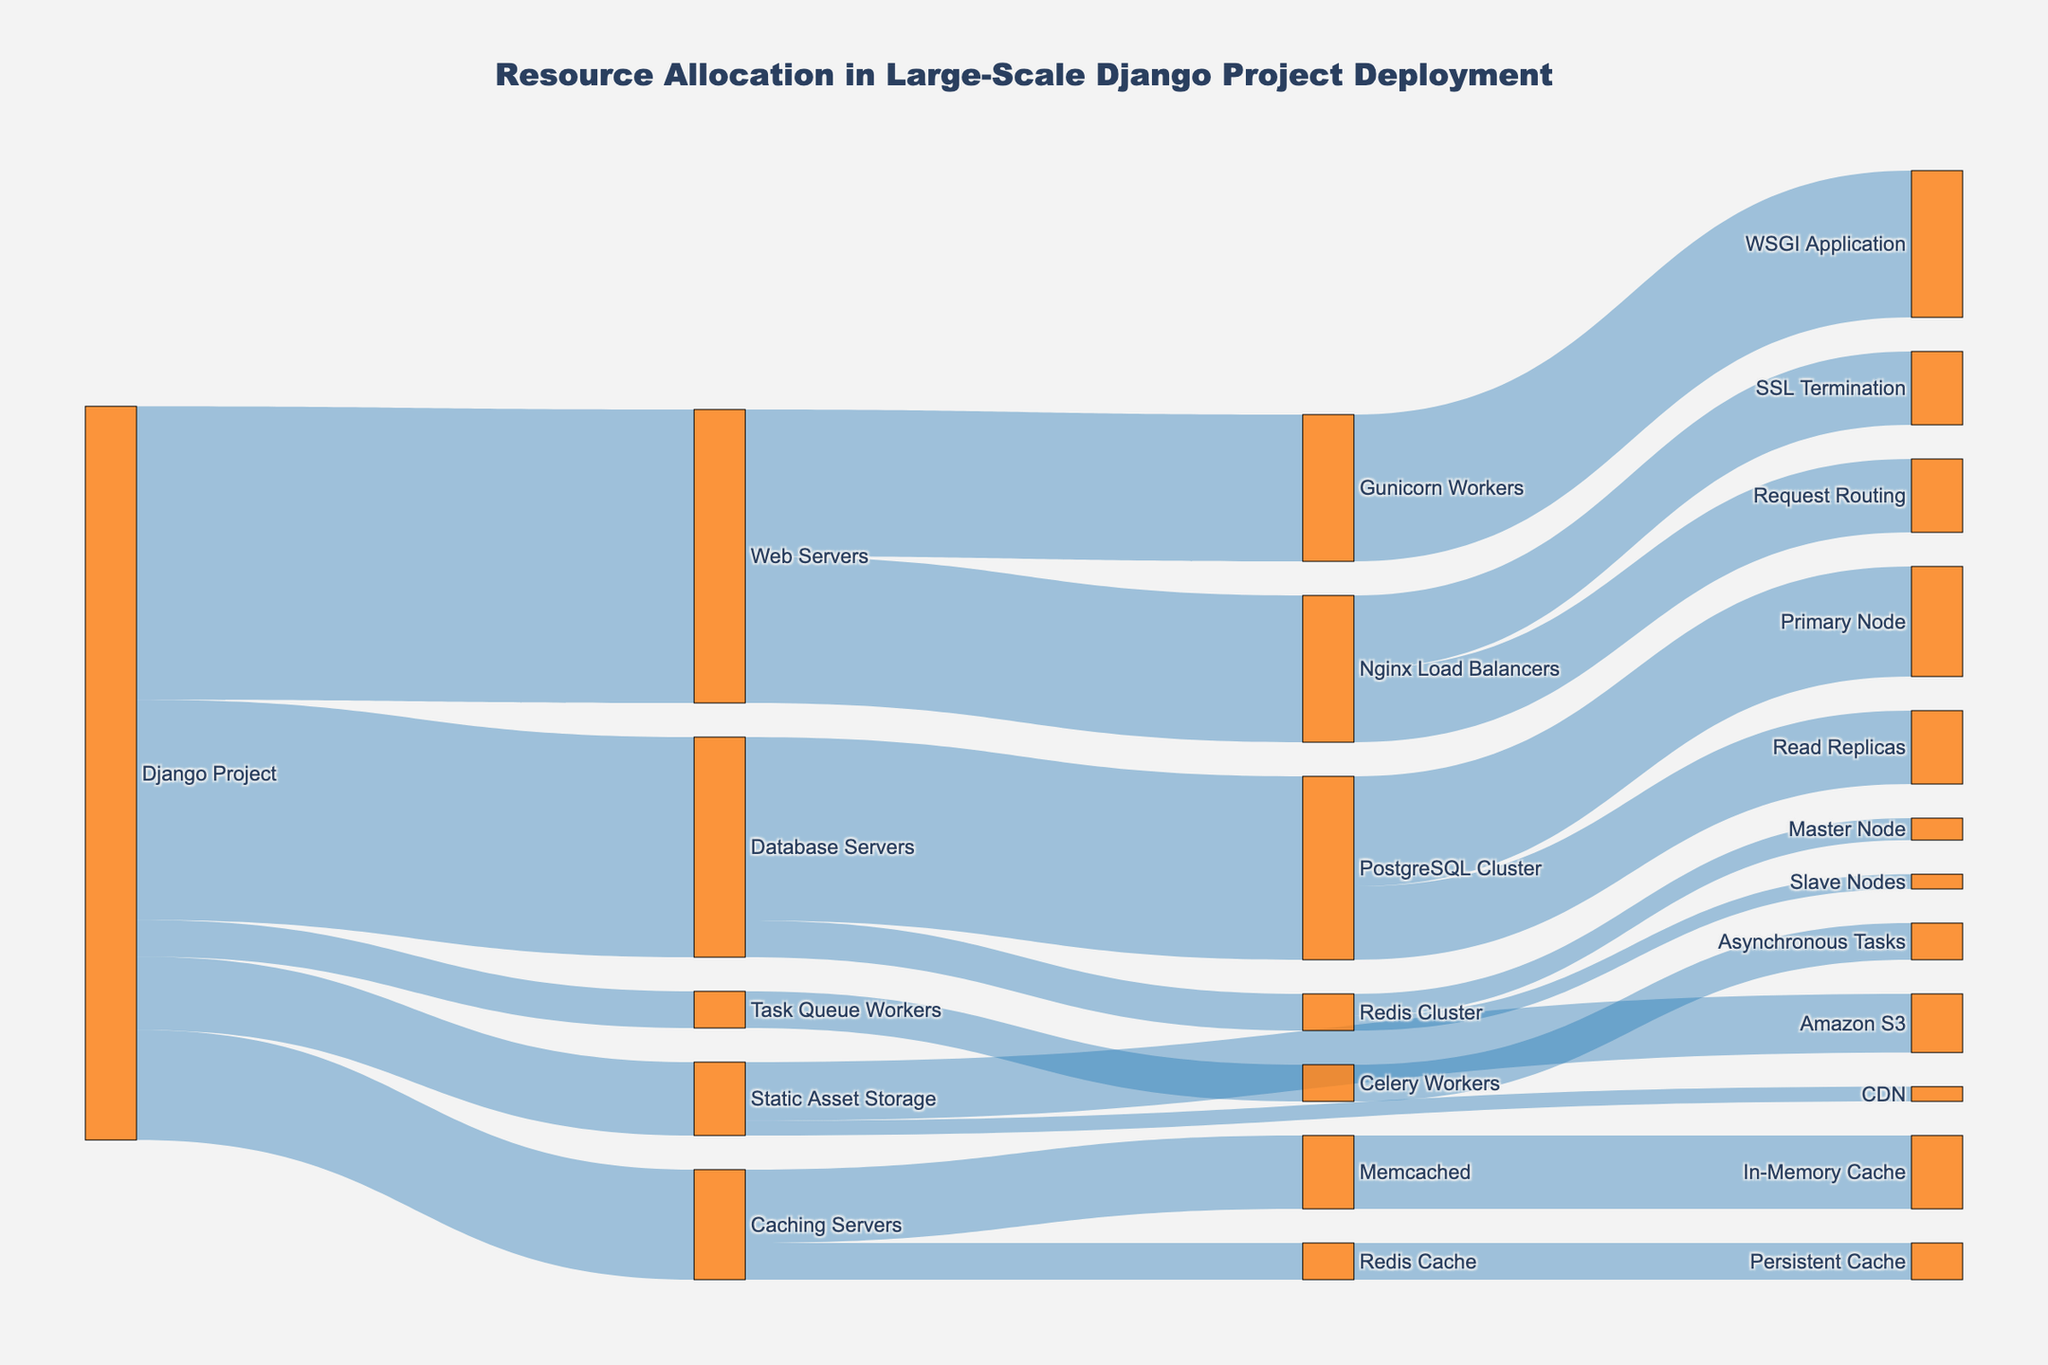What is the main title of the figure? The title is usually located at the top of the diagram and gives an overall description of the visual. In this case, it is explicitly stated in the code provided.
Answer: Resource Allocation in Large-Scale Django Project Deployment What is the total allocation from the Django Project node? To find the total allocation from the Django Project node, sum the values of all outbound flows from this node: 30 (Database Servers) + 40 (Web Servers) + 15 (Caching Servers) + 10 (Static Asset Storage) + 5 (Task Queue Workers).
Answer: 100 Which resource receives the highest allocation from the Django Project? Compare the values flowing from the Django Project to various resources: 30 (Database Servers), 40 (Web Servers), 15 (Caching Servers), 10 (Static Asset Storage), and 5 (Task Queue Workers). The highest value is 40, directed to Web Servers.
Answer: Web Servers How does the allocation split within the Database Servers? Look at the subsequent flows from Database Servers: 25 (PostgreSQL Cluster) + 5 (Redis Cluster). Add these to verify the total allocation divides correctly.
Answer: PostgreSQL Cluster receives 25 and Redis Cluster receives 5 What is the combined value of resource allocations specifically directed to any type of caching (Memcached and Redis Cache)? Add the values allocated to both Memcached and Redis Cache from Caching Servers: 10 (Memcached) + 5 (Redis Cache).
Answer: 15 How does the allocation distribution compare between Memcached and Redis Cache? Examine the allocations to each from Caching Servers: 10 to Memcached and 5 to Redis Cache. Memcached receives twice the allocation of Redis Cache.
Answer: Memcached receives more Which node directly handles the asynchronous tasks? Identify the flow ending at the node related to tasks: 5 from Task Queue Workers directed to Celery Workers. Celery Workers are responsible for handling asynchronous tasks.
Answer: Celery Workers What resource has the smallest allocation from the Django Project, and how much? Determine the smallest value among the allocations from Django Project to Database Servers (30), Web Servers (40), Caching Servers (15), Static Asset Storage (10), and Task Queue Workers (5). The smallest allocation is 5 directed to Task Queue Workers.
Answer: Task Queue Workers How are static assets distributed from Static Asset Storage? Inspect the values flowing from Static Asset Storage: Amazon S3 (8) and CDN (2). These add up to the total from Static Asset Storage.
Answer: Amazon S3 receives 8 and CDN receives 2 Between PostgreSQL Cluster and Nginx Load Balancers, which one gets a higher allocation, and by how much? Compare values: PostgreSQL Cluster receives 25 while Nginx Load Balancers receive 20. The difference is 25 - 20 = 5.
Answer: PostgreSQL Cluster by 5 